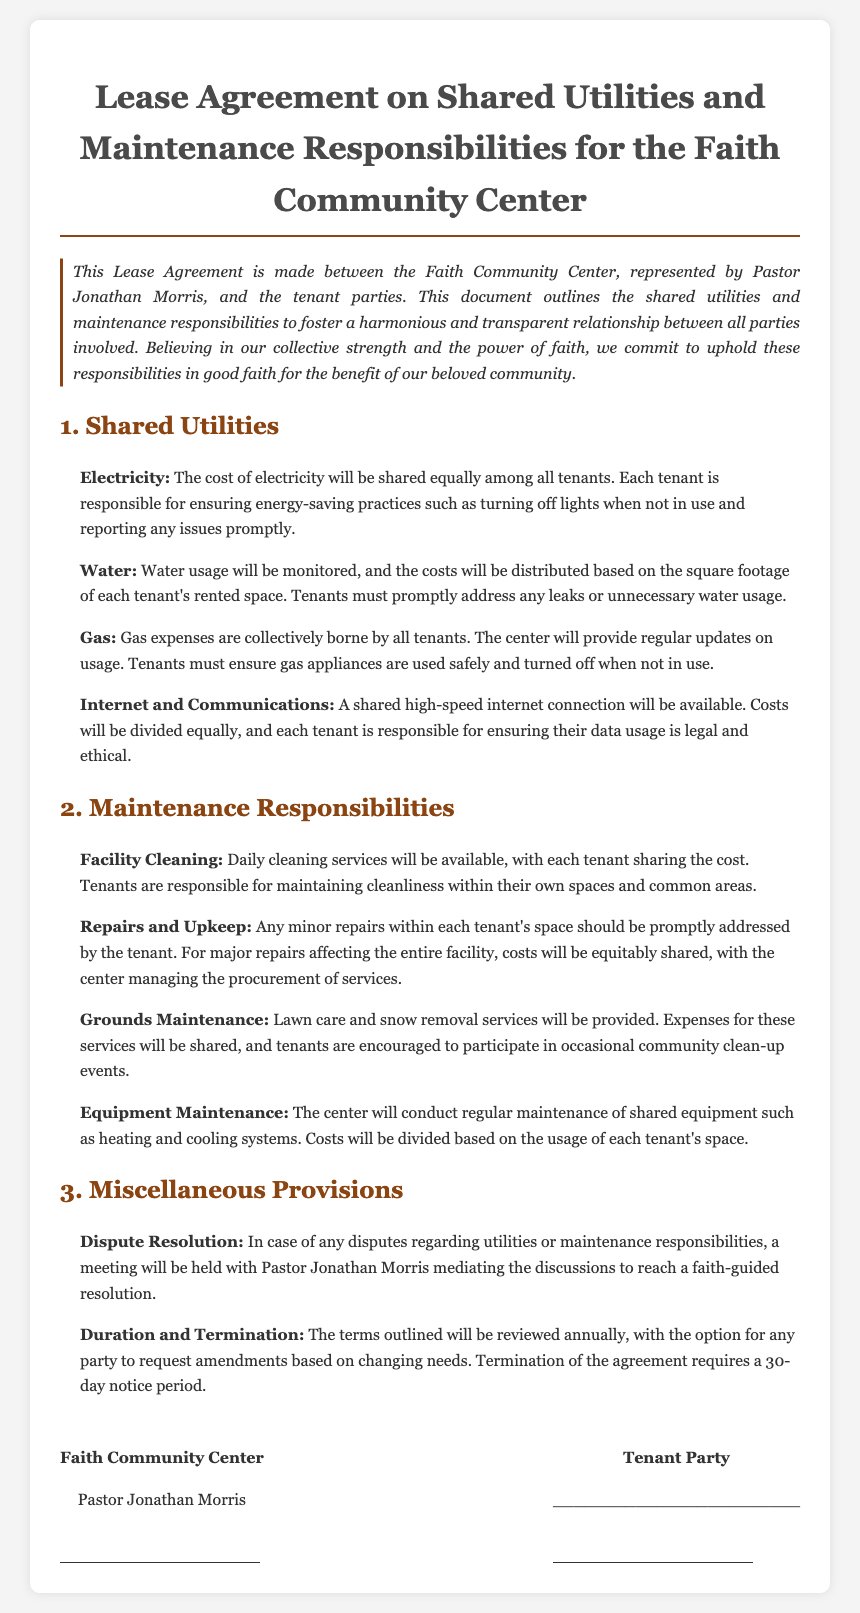What is the document's title? The title states the nature of the agreement regarding shared utilities and maintenance responsibilities specifically for the Faith Community Center.
Answer: Lease Agreement on Shared Utilities and Maintenance Responsibilities for the Faith Community Center Who is the represented pastor in the agreement? The document identifies Pastor Jonathan Morris as the representative of the Faith Community Center.
Answer: Pastor Jonathan Morris How will the electricity costs be shared? The document mentions that electricity costs will be split equally among all tenants.
Answer: Shared equally What is the responsibility of tenants regarding water usage? Tenants must address any leaks or unnecessary water usage as stated in the water section.
Answer: Promptly address leaks Who mediates disputes regarding utilities or maintenance? The agreement specifies that Pastor Jonathan Morris will mediate any disputes that arise.
Answer: Pastor Jonathan Morris What is required for the termination of the agreement? The document outlines that a 30-day notice period is required for the termination of the lease agreement.
Answer: 30-day notice period How are minor repairs handled according to the agreement? Minor repairs within each tenant's space should be promptly addressed by the tenant as outlined in the maintenance responsibilities.
Answer: Promptly addressed by the tenant What type of cleaning services are provided? The document states that daily cleaning services will be available, with costs shared among tenants.
Answer: Daily cleaning services What will be provided for grounds maintenance? The lease agreement mentions that lawn care and snow removal services will be provided for the community center.
Answer: Lawn care and snow removal services 